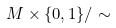<formula> <loc_0><loc_0><loc_500><loc_500>M \times \{ 0 , 1 \} / \sim</formula> 